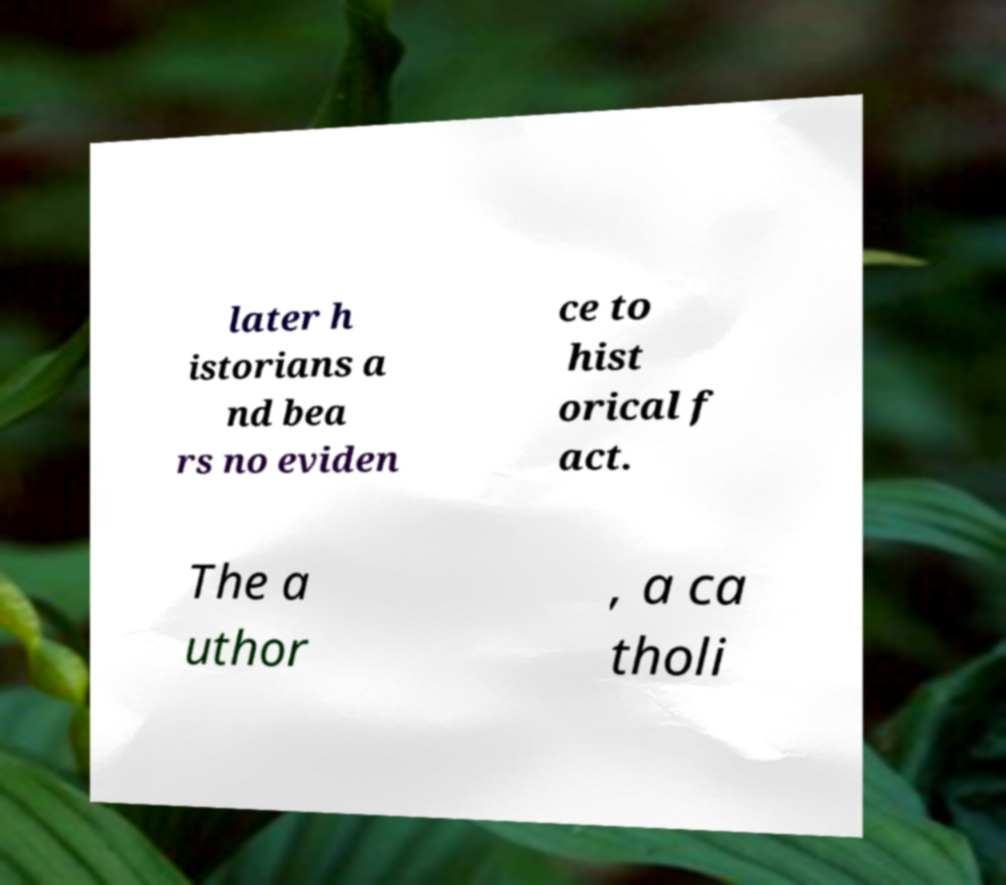Can you accurately transcribe the text from the provided image for me? later h istorians a nd bea rs no eviden ce to hist orical f act. The a uthor , a ca tholi 